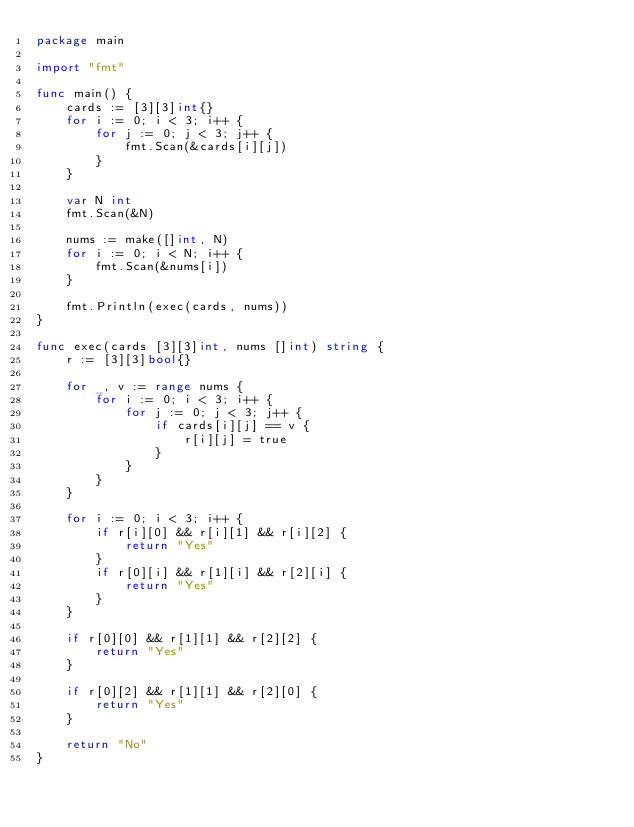Convert code to text. <code><loc_0><loc_0><loc_500><loc_500><_Go_>package main

import "fmt"

func main() {
	cards := [3][3]int{}
	for i := 0; i < 3; i++ {
		for j := 0; j < 3; j++ {
			fmt.Scan(&cards[i][j])
		}
	}

	var N int
	fmt.Scan(&N)

	nums := make([]int, N)
	for i := 0; i < N; i++ {
		fmt.Scan(&nums[i])
	}

	fmt.Println(exec(cards, nums))
}

func exec(cards [3][3]int, nums []int) string {
	r := [3][3]bool{}

	for _, v := range nums {
		for i := 0; i < 3; i++ {
			for j := 0; j < 3; j++ {
				if cards[i][j] == v {
					r[i][j] = true
				}
			}
		}
	}

	for i := 0; i < 3; i++ {
		if r[i][0] && r[i][1] && r[i][2] {
			return "Yes"
		}
		if r[0][i] && r[1][i] && r[2][i] {
			return "Yes"
		}
	}

	if r[0][0] && r[1][1] && r[2][2] {
		return "Yes"
	}

	if r[0][2] && r[1][1] && r[2][0] {
		return "Yes"
	}

	return "No"
}
</code> 